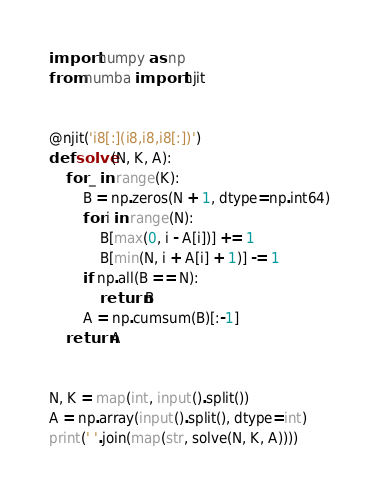Convert code to text. <code><loc_0><loc_0><loc_500><loc_500><_Python_>import numpy as np
from numba import njit


@njit('i8[:](i8,i8,i8[:])')
def solve(N, K, A):
    for _ in range(K):
        B = np.zeros(N + 1, dtype=np.int64)
        for i in range(N):
            B[max(0, i - A[i])] += 1
            B[min(N, i + A[i] + 1)] -= 1
        if np.all(B == N):
            return B
        A = np.cumsum(B)[:-1]
    return A


N, K = map(int, input().split())
A = np.array(input().split(), dtype=int)
print(' '.join(map(str, solve(N, K, A))))
</code> 